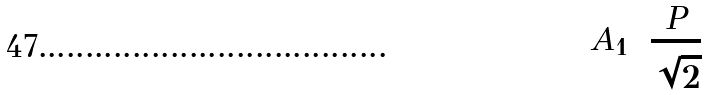<formula> <loc_0><loc_0><loc_500><loc_500>A _ { 1 } = \frac { P } { \sqrt { 2 } }</formula> 